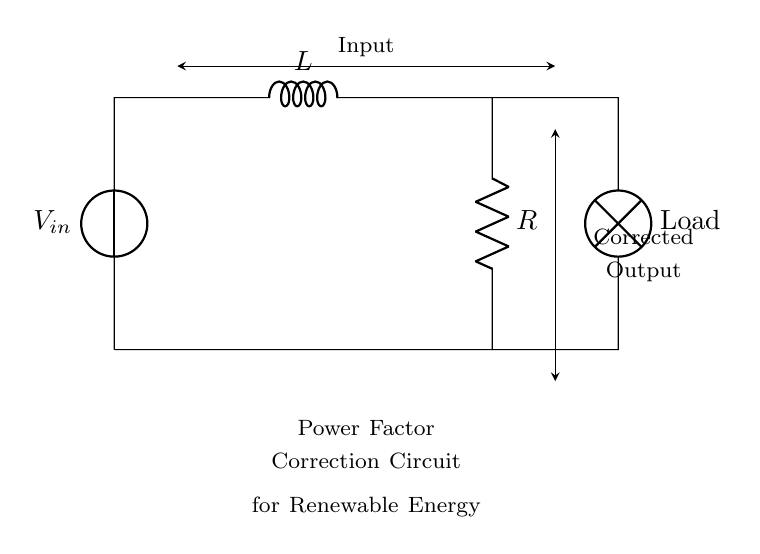What is the input voltage of the circuit? The input voltage is represented by the voltage source symbol on the left side of the circuit diagram, labeled V_in.
Answer: V_in What type of load is connected to the circuit? The load is indicated by the lamp symbol at the lower right side of the diagram, which specifies that it is a lamp acting as the load.
Answer: Lamp How many components are used in the power factor correction circuit? The circuit consists of three main components: a voltage source, an inductor, and a resistor, along with the load (lamp), totaling four components.
Answer: Four Which components are responsible for power factor correction? The inductor and the resistor work together to correct the power factor in this circuit. The inductor provides reactance, while the resistor provides real power.
Answer: Inductor and Resistor What is the purpose of power factor correction in renewable energy? Power factor correction is used to improve the efficiency and stability of the energy supply by reducing reactive power, which is crucial for adapting renewable energy sources, often variable, to stable grid conditions.
Answer: Improve efficiency 